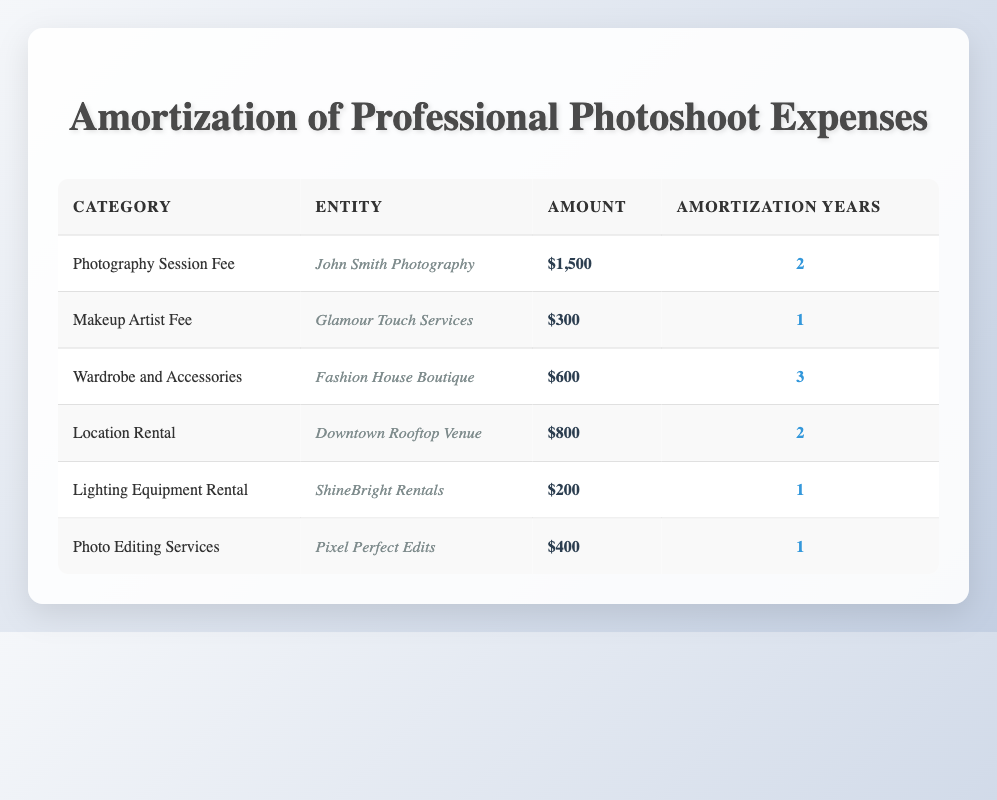What is the total amount spent on the Photography Session Fee? The Photography Session Fee is $1,500, which can be found directly in the table under that category.
Answer: 1500 Which expense has the shortest amortization period? The expense with the shortest amortization period is the Makeup Artist Fee, which has a period of 1 year, as indicated in the table.
Answer: Makeup Artist Fee How much will the Wardrobe and Accessories cost per year? The total cost for Wardrobe and Accessories is $600, and it will be amortized over 3 years. Therefore, to find the yearly cost, we divide: $600 by 3, which equals $200 per year.
Answer: 200 Is the Lighting Equipment Rental amortized over 2 years? The Lighting Equipment Rental is amortized for 1 year, as shown in the table, so the statement is false.
Answer: No What is the combined total amount for all expenses amortized over 2 years? The expenses amortized over 2 years are the Photography Session Fee ($1,500) and Location Rental ($800). To combine them, we add $1,500 + $800, resulting in a total of $2,300.
Answer: 2300 